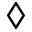<formula> <loc_0><loc_0><loc_500><loc_500>\diamondsuit</formula> 